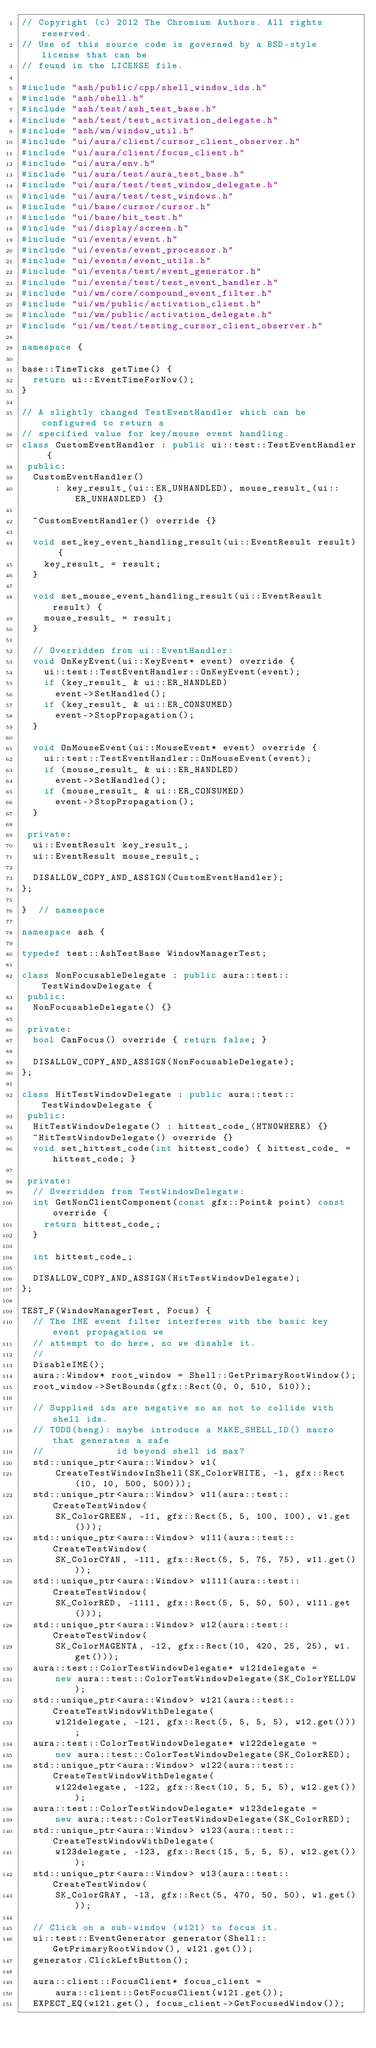Convert code to text. <code><loc_0><loc_0><loc_500><loc_500><_C++_>// Copyright (c) 2012 The Chromium Authors. All rights reserved.
// Use of this source code is governed by a BSD-style license that can be
// found in the LICENSE file.

#include "ash/public/cpp/shell_window_ids.h"
#include "ash/shell.h"
#include "ash/test/ash_test_base.h"
#include "ash/test/test_activation_delegate.h"
#include "ash/wm/window_util.h"
#include "ui/aura/client/cursor_client_observer.h"
#include "ui/aura/client/focus_client.h"
#include "ui/aura/env.h"
#include "ui/aura/test/aura_test_base.h"
#include "ui/aura/test/test_window_delegate.h"
#include "ui/aura/test/test_windows.h"
#include "ui/base/cursor/cursor.h"
#include "ui/base/hit_test.h"
#include "ui/display/screen.h"
#include "ui/events/event.h"
#include "ui/events/event_processor.h"
#include "ui/events/event_utils.h"
#include "ui/events/test/event_generator.h"
#include "ui/events/test/test_event_handler.h"
#include "ui/wm/core/compound_event_filter.h"
#include "ui/wm/public/activation_client.h"
#include "ui/wm/public/activation_delegate.h"
#include "ui/wm/test/testing_cursor_client_observer.h"

namespace {

base::TimeTicks getTime() {
  return ui::EventTimeForNow();
}

// A slightly changed TestEventHandler which can be configured to return a
// specified value for key/mouse event handling.
class CustomEventHandler : public ui::test::TestEventHandler {
 public:
  CustomEventHandler()
      : key_result_(ui::ER_UNHANDLED), mouse_result_(ui::ER_UNHANDLED) {}

  ~CustomEventHandler() override {}

  void set_key_event_handling_result(ui::EventResult result) {
    key_result_ = result;
  }

  void set_mouse_event_handling_result(ui::EventResult result) {
    mouse_result_ = result;
  }

  // Overridden from ui::EventHandler:
  void OnKeyEvent(ui::KeyEvent* event) override {
    ui::test::TestEventHandler::OnKeyEvent(event);
    if (key_result_ & ui::ER_HANDLED)
      event->SetHandled();
    if (key_result_ & ui::ER_CONSUMED)
      event->StopPropagation();
  }

  void OnMouseEvent(ui::MouseEvent* event) override {
    ui::test::TestEventHandler::OnMouseEvent(event);
    if (mouse_result_ & ui::ER_HANDLED)
      event->SetHandled();
    if (mouse_result_ & ui::ER_CONSUMED)
      event->StopPropagation();
  }

 private:
  ui::EventResult key_result_;
  ui::EventResult mouse_result_;

  DISALLOW_COPY_AND_ASSIGN(CustomEventHandler);
};

}  // namespace

namespace ash {

typedef test::AshTestBase WindowManagerTest;

class NonFocusableDelegate : public aura::test::TestWindowDelegate {
 public:
  NonFocusableDelegate() {}

 private:
  bool CanFocus() override { return false; }

  DISALLOW_COPY_AND_ASSIGN(NonFocusableDelegate);
};

class HitTestWindowDelegate : public aura::test::TestWindowDelegate {
 public:
  HitTestWindowDelegate() : hittest_code_(HTNOWHERE) {}
  ~HitTestWindowDelegate() override {}
  void set_hittest_code(int hittest_code) { hittest_code_ = hittest_code; }

 private:
  // Overridden from TestWindowDelegate:
  int GetNonClientComponent(const gfx::Point& point) const override {
    return hittest_code_;
  }

  int hittest_code_;

  DISALLOW_COPY_AND_ASSIGN(HitTestWindowDelegate);
};

TEST_F(WindowManagerTest, Focus) {
  // The IME event filter interferes with the basic key event propagation we
  // attempt to do here, so we disable it.
  //
  DisableIME();
  aura::Window* root_window = Shell::GetPrimaryRootWindow();
  root_window->SetBounds(gfx::Rect(0, 0, 510, 510));

  // Supplied ids are negative so as not to collide with shell ids.
  // TODO(beng): maybe introduce a MAKE_SHELL_ID() macro that generates a safe
  //             id beyond shell id max?
  std::unique_ptr<aura::Window> w1(
      CreateTestWindowInShell(SK_ColorWHITE, -1, gfx::Rect(10, 10, 500, 500)));
  std::unique_ptr<aura::Window> w11(aura::test::CreateTestWindow(
      SK_ColorGREEN, -11, gfx::Rect(5, 5, 100, 100), w1.get()));
  std::unique_ptr<aura::Window> w111(aura::test::CreateTestWindow(
      SK_ColorCYAN, -111, gfx::Rect(5, 5, 75, 75), w11.get()));
  std::unique_ptr<aura::Window> w1111(aura::test::CreateTestWindow(
      SK_ColorRED, -1111, gfx::Rect(5, 5, 50, 50), w111.get()));
  std::unique_ptr<aura::Window> w12(aura::test::CreateTestWindow(
      SK_ColorMAGENTA, -12, gfx::Rect(10, 420, 25, 25), w1.get()));
  aura::test::ColorTestWindowDelegate* w121delegate =
      new aura::test::ColorTestWindowDelegate(SK_ColorYELLOW);
  std::unique_ptr<aura::Window> w121(aura::test::CreateTestWindowWithDelegate(
      w121delegate, -121, gfx::Rect(5, 5, 5, 5), w12.get()));
  aura::test::ColorTestWindowDelegate* w122delegate =
      new aura::test::ColorTestWindowDelegate(SK_ColorRED);
  std::unique_ptr<aura::Window> w122(aura::test::CreateTestWindowWithDelegate(
      w122delegate, -122, gfx::Rect(10, 5, 5, 5), w12.get()));
  aura::test::ColorTestWindowDelegate* w123delegate =
      new aura::test::ColorTestWindowDelegate(SK_ColorRED);
  std::unique_ptr<aura::Window> w123(aura::test::CreateTestWindowWithDelegate(
      w123delegate, -123, gfx::Rect(15, 5, 5, 5), w12.get()));
  std::unique_ptr<aura::Window> w13(aura::test::CreateTestWindow(
      SK_ColorGRAY, -13, gfx::Rect(5, 470, 50, 50), w1.get()));

  // Click on a sub-window (w121) to focus it.
  ui::test::EventGenerator generator(Shell::GetPrimaryRootWindow(), w121.get());
  generator.ClickLeftButton();

  aura::client::FocusClient* focus_client =
      aura::client::GetFocusClient(w121.get());
  EXPECT_EQ(w121.get(), focus_client->GetFocusedWindow());
</code> 